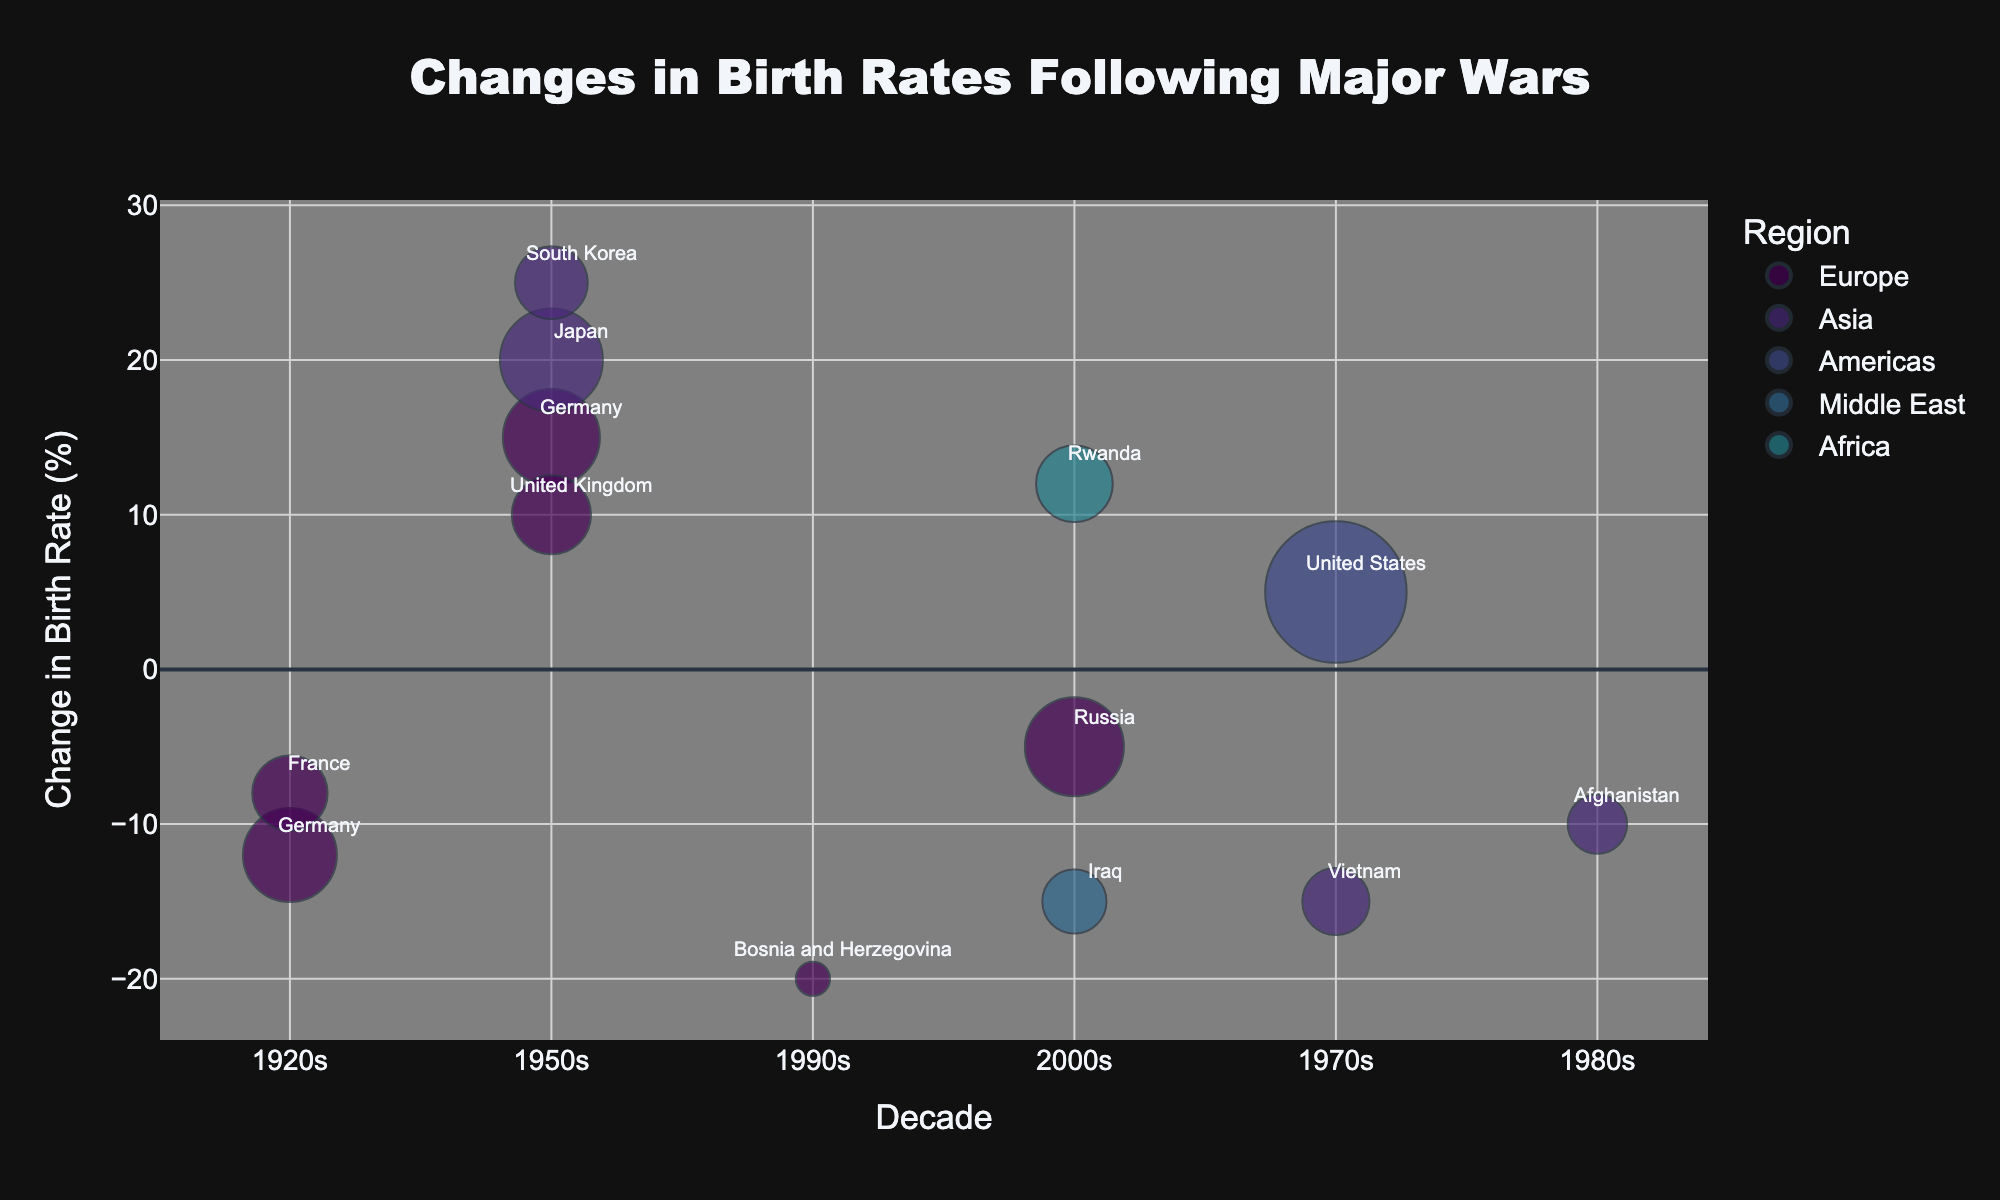What's the overall trend in birth rates in Europe during the 1920s and 1950s? Examine the data points for Europe during the 1920s (Germany and France) and 1950s (Germany and the United Kingdom). In the 1920s, both Germany and France experienced a decrease in birth rates (-12% and -8%, respectively). Conversely, in the 1950s, both Germany and the United Kingdom saw an increase in birth rates (+15% and +10%, respectively). Therefore, the overall trend in Europe shifts from a decline in the 1920s to an increase in the 1950s.
Answer: From decrease to increase Which country observed the largest increase in birth rates, and what was the value? Scan through the data points to find the highest positive change in birth rates. South Korea in the 1950s observed the largest increase in birth rates with a value of +25%.
Answer: South Korea, +25% What is the range of birth rate changes for countries in Asia? Identify the maximum and minimum birth rate changes for the Asian countries listed. The highest increase is for South Korea in the 1950s (+25%), and the largest decrease is for Vietnam in the 1970s (-15%). The range is obtained by computing the difference between these two values: 25% - (-15%) = 40%.
Answer: 40% What was the birth rate change in the United States during the 1970s, and how does its population impact compare to other countries? Look at the data point for the United States in the 1970s. The change in birth rate is +5%, and its population impact is 10.2 million. Compare this to other population impacts, and observe that the United States has the largest population impact among all listed countries.
Answer: +5%, largest population impact Which region has the highest number of countries with decreasing birth rates and how many? Review the data points and count the number of countries with decreasing birth rates per region. Asia has three countries with decreasing birth rates (Vietnam, Afghanistan, and Iraq), which is the highest among all regions.
Answer: Asia, three countries 